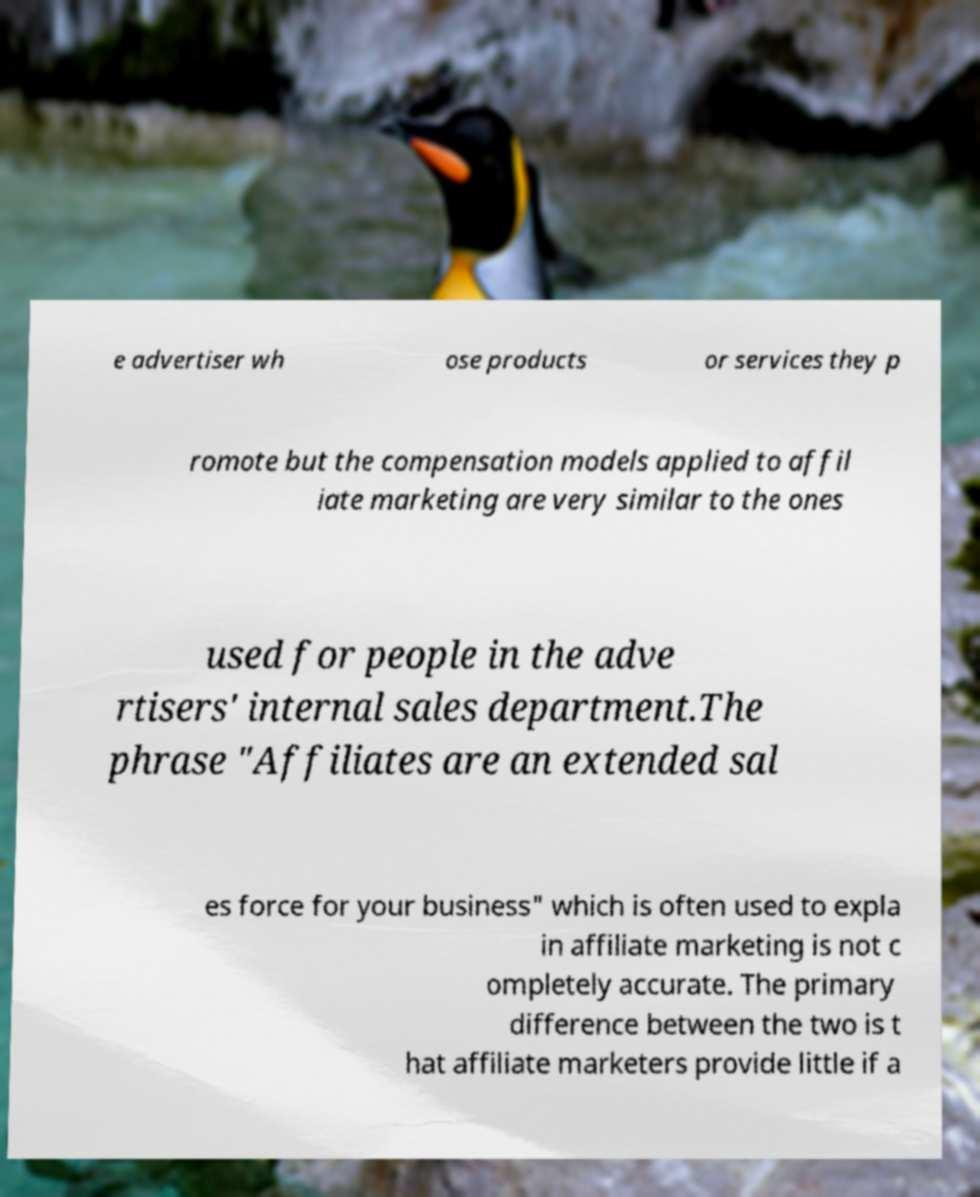There's text embedded in this image that I need extracted. Can you transcribe it verbatim? e advertiser wh ose products or services they p romote but the compensation models applied to affil iate marketing are very similar to the ones used for people in the adve rtisers' internal sales department.The phrase "Affiliates are an extended sal es force for your business" which is often used to expla in affiliate marketing is not c ompletely accurate. The primary difference between the two is t hat affiliate marketers provide little if a 